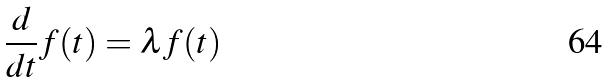Convert formula to latex. <formula><loc_0><loc_0><loc_500><loc_500>\frac { d } { d t } f ( t ) = \lambda f ( t )</formula> 